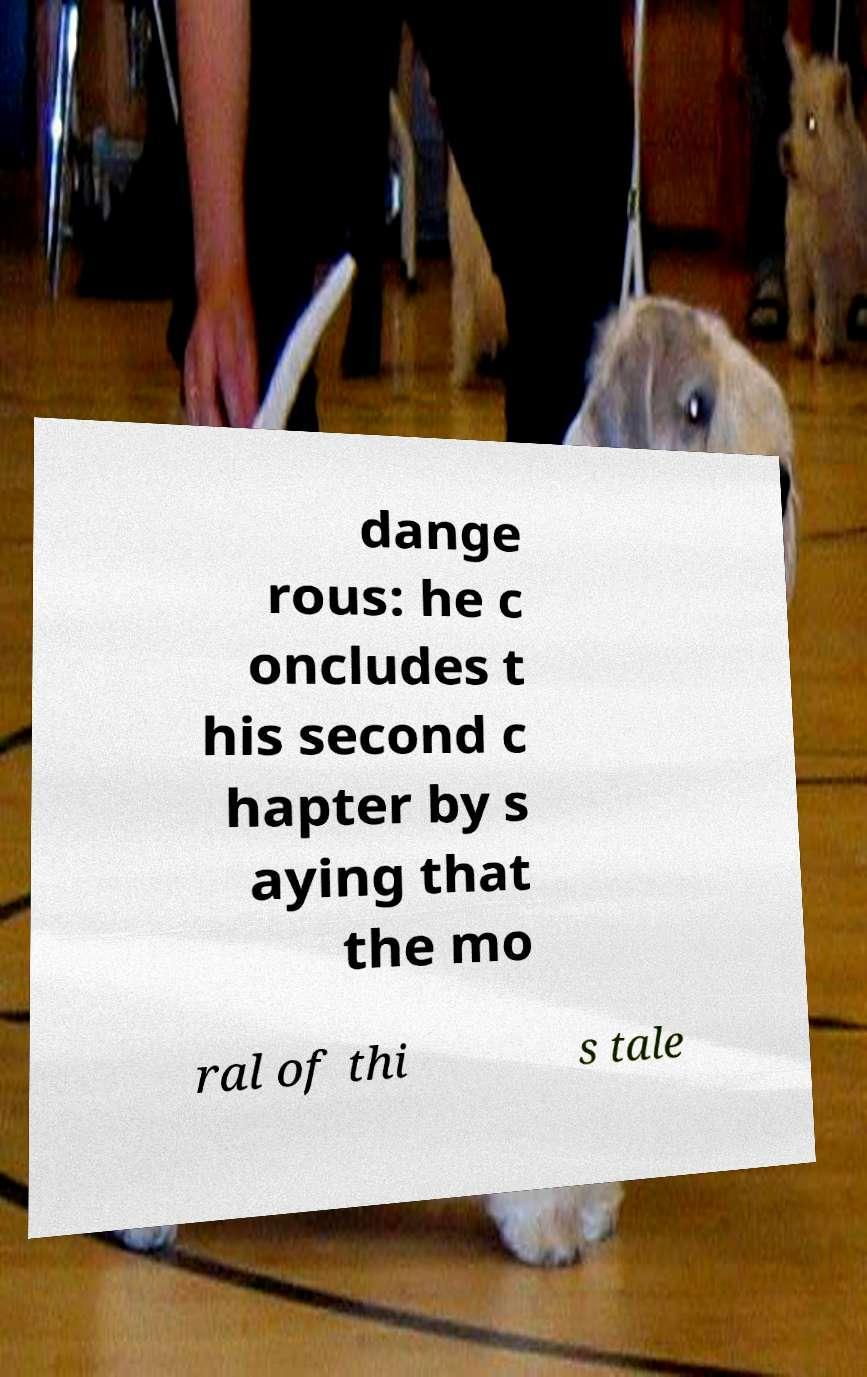What messages or text are displayed in this image? I need them in a readable, typed format. dange rous: he c oncludes t his second c hapter by s aying that the mo ral of thi s tale 